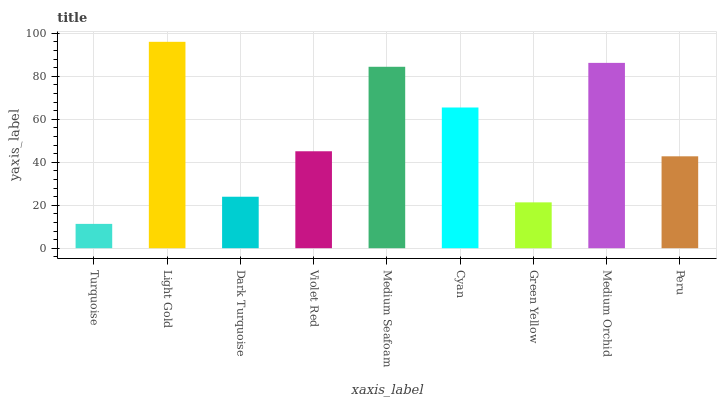Is Turquoise the minimum?
Answer yes or no. Yes. Is Light Gold the maximum?
Answer yes or no. Yes. Is Dark Turquoise the minimum?
Answer yes or no. No. Is Dark Turquoise the maximum?
Answer yes or no. No. Is Light Gold greater than Dark Turquoise?
Answer yes or no. Yes. Is Dark Turquoise less than Light Gold?
Answer yes or no. Yes. Is Dark Turquoise greater than Light Gold?
Answer yes or no. No. Is Light Gold less than Dark Turquoise?
Answer yes or no. No. Is Violet Red the high median?
Answer yes or no. Yes. Is Violet Red the low median?
Answer yes or no. Yes. Is Medium Seafoam the high median?
Answer yes or no. No. Is Cyan the low median?
Answer yes or no. No. 